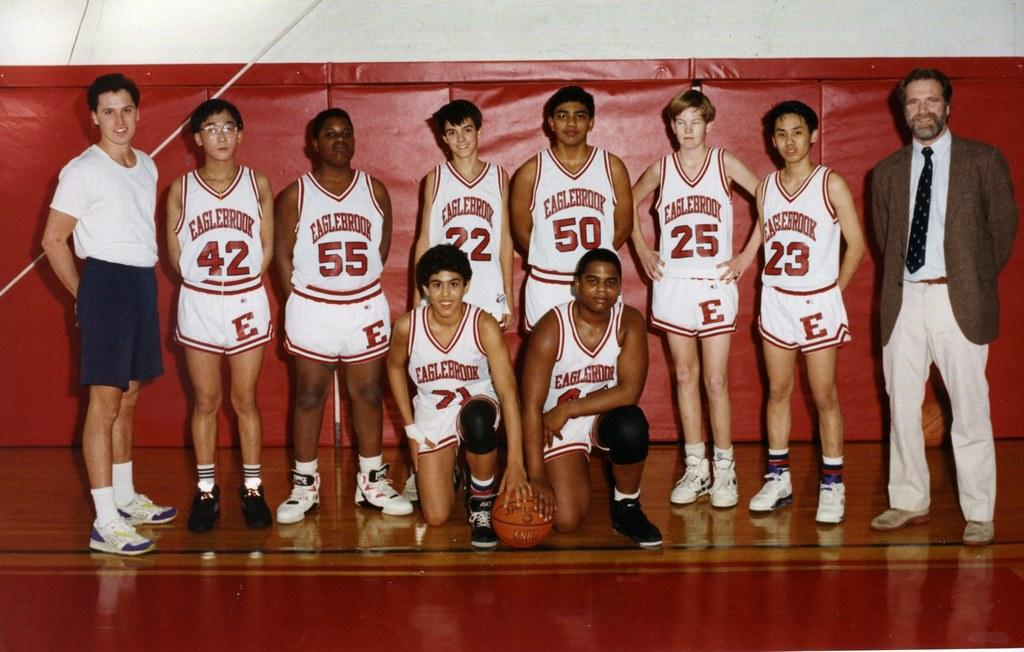What is the main subject of the image? The main subject of the image is a group of people. What object is in front of the group of people? There is a ball in front of the group of people. What object is behind the group of people? There is a rope behind the group of people. What type of hammer is being used by the group of people in the image? There is no hammer present in the image. What door is being opened or closed by the group of people in the image? There is no door present in the image. 